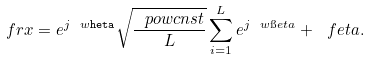Convert formula to latex. <formula><loc_0><loc_0><loc_500><loc_500>\ f r x = e ^ { j \ w \tt h e t a } \sqrt { \frac { \ p o w c n s t } { L } } \sum _ { i = 1 } ^ { L } e ^ { j \ w \i e t a } + \ f e t a .</formula> 